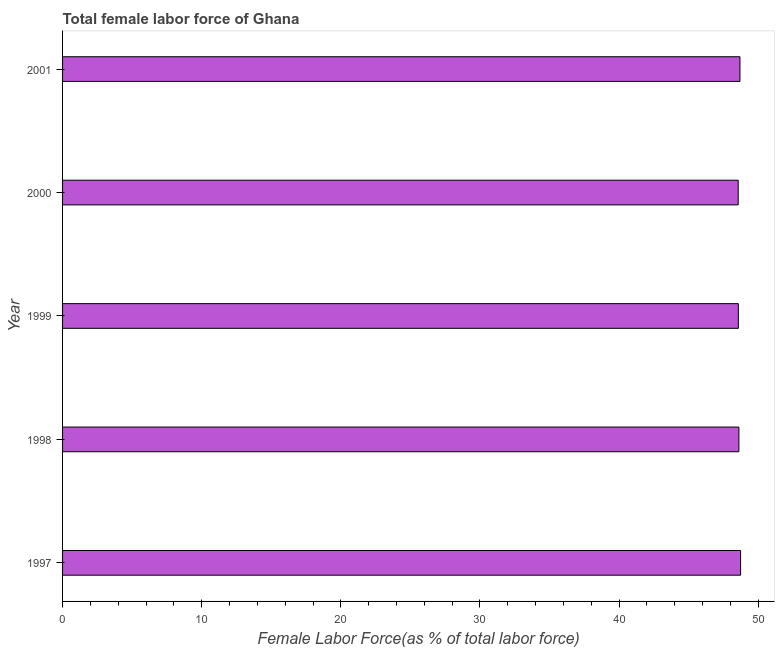Does the graph contain grids?
Offer a terse response. No. What is the title of the graph?
Your answer should be very brief. Total female labor force of Ghana. What is the label or title of the X-axis?
Your response must be concise. Female Labor Force(as % of total labor force). What is the total female labor force in 1999?
Give a very brief answer. 48.57. Across all years, what is the maximum total female labor force?
Give a very brief answer. 48.73. Across all years, what is the minimum total female labor force?
Provide a succinct answer. 48.56. In which year was the total female labor force maximum?
Your answer should be compact. 1997. In which year was the total female labor force minimum?
Ensure brevity in your answer.  2000. What is the sum of the total female labor force?
Your response must be concise. 243.15. What is the difference between the total female labor force in 1998 and 1999?
Your response must be concise. 0.04. What is the average total female labor force per year?
Give a very brief answer. 48.63. What is the median total female labor force?
Your response must be concise. 48.61. In how many years, is the total female labor force greater than 18 %?
Provide a short and direct response. 5. What is the ratio of the total female labor force in 1997 to that in 1999?
Your response must be concise. 1. Is the total female labor force in 1997 less than that in 2000?
Offer a very short reply. No. Is the difference between the total female labor force in 1997 and 2001 greater than the difference between any two years?
Provide a short and direct response. No. What is the difference between the highest and the second highest total female labor force?
Provide a short and direct response. 0.04. Is the sum of the total female labor force in 1997 and 2001 greater than the maximum total female labor force across all years?
Keep it short and to the point. Yes. What is the difference between the highest and the lowest total female labor force?
Provide a succinct answer. 0.17. In how many years, is the total female labor force greater than the average total female labor force taken over all years?
Offer a terse response. 2. How many bars are there?
Offer a terse response. 5. Are all the bars in the graph horizontal?
Keep it short and to the point. Yes. Are the values on the major ticks of X-axis written in scientific E-notation?
Your answer should be compact. No. What is the Female Labor Force(as % of total labor force) in 1997?
Provide a short and direct response. 48.73. What is the Female Labor Force(as % of total labor force) of 1998?
Your answer should be compact. 48.61. What is the Female Labor Force(as % of total labor force) of 1999?
Your response must be concise. 48.57. What is the Female Labor Force(as % of total labor force) in 2000?
Keep it short and to the point. 48.56. What is the Female Labor Force(as % of total labor force) of 2001?
Give a very brief answer. 48.68. What is the difference between the Female Labor Force(as % of total labor force) in 1997 and 1998?
Make the answer very short. 0.12. What is the difference between the Female Labor Force(as % of total labor force) in 1997 and 1999?
Your answer should be compact. 0.16. What is the difference between the Female Labor Force(as % of total labor force) in 1997 and 2000?
Your answer should be compact. 0.17. What is the difference between the Female Labor Force(as % of total labor force) in 1997 and 2001?
Offer a terse response. 0.05. What is the difference between the Female Labor Force(as % of total labor force) in 1998 and 1999?
Offer a very short reply. 0.04. What is the difference between the Female Labor Force(as % of total labor force) in 1998 and 2000?
Make the answer very short. 0.05. What is the difference between the Female Labor Force(as % of total labor force) in 1998 and 2001?
Keep it short and to the point. -0.08. What is the difference between the Female Labor Force(as % of total labor force) in 1999 and 2000?
Provide a short and direct response. 0.01. What is the difference between the Female Labor Force(as % of total labor force) in 1999 and 2001?
Provide a short and direct response. -0.12. What is the difference between the Female Labor Force(as % of total labor force) in 2000 and 2001?
Your answer should be very brief. -0.13. What is the ratio of the Female Labor Force(as % of total labor force) in 1997 to that in 1998?
Provide a succinct answer. 1. What is the ratio of the Female Labor Force(as % of total labor force) in 1997 to that in 1999?
Keep it short and to the point. 1. What is the ratio of the Female Labor Force(as % of total labor force) in 1997 to that in 2000?
Provide a short and direct response. 1. What is the ratio of the Female Labor Force(as % of total labor force) in 1998 to that in 2000?
Offer a very short reply. 1. What is the ratio of the Female Labor Force(as % of total labor force) in 1999 to that in 2000?
Offer a very short reply. 1. What is the ratio of the Female Labor Force(as % of total labor force) in 1999 to that in 2001?
Provide a succinct answer. 1. 